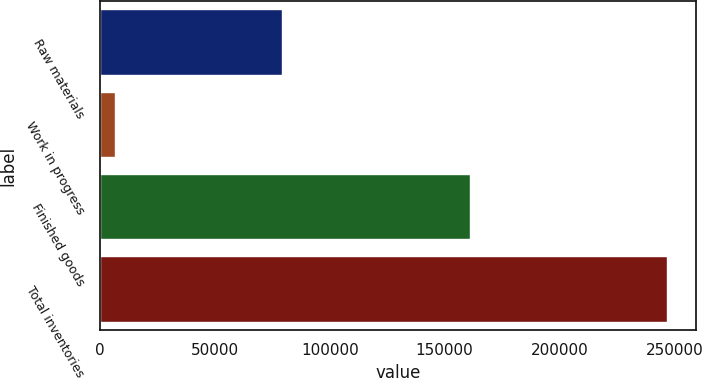Convert chart to OTSL. <chart><loc_0><loc_0><loc_500><loc_500><bar_chart><fcel>Raw materials<fcel>Work in progress<fcel>Finished goods<fcel>Total inventories<nl><fcel>79189<fcel>6561<fcel>161097<fcel>246847<nl></chart> 